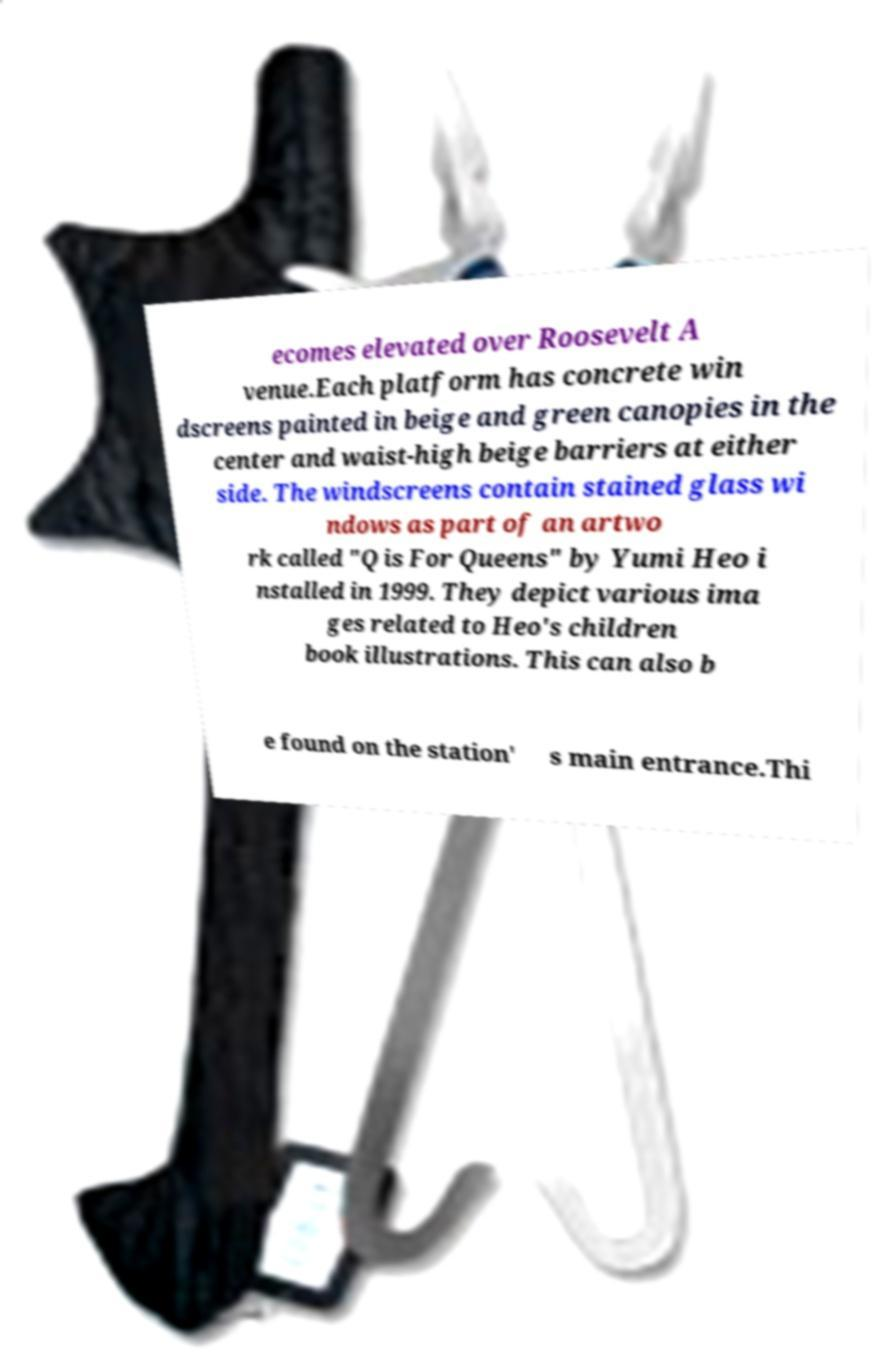Could you extract and type out the text from this image? ecomes elevated over Roosevelt A venue.Each platform has concrete win dscreens painted in beige and green canopies in the center and waist-high beige barriers at either side. The windscreens contain stained glass wi ndows as part of an artwo rk called "Q is For Queens" by Yumi Heo i nstalled in 1999. They depict various ima ges related to Heo's children book illustrations. This can also b e found on the station' s main entrance.Thi 